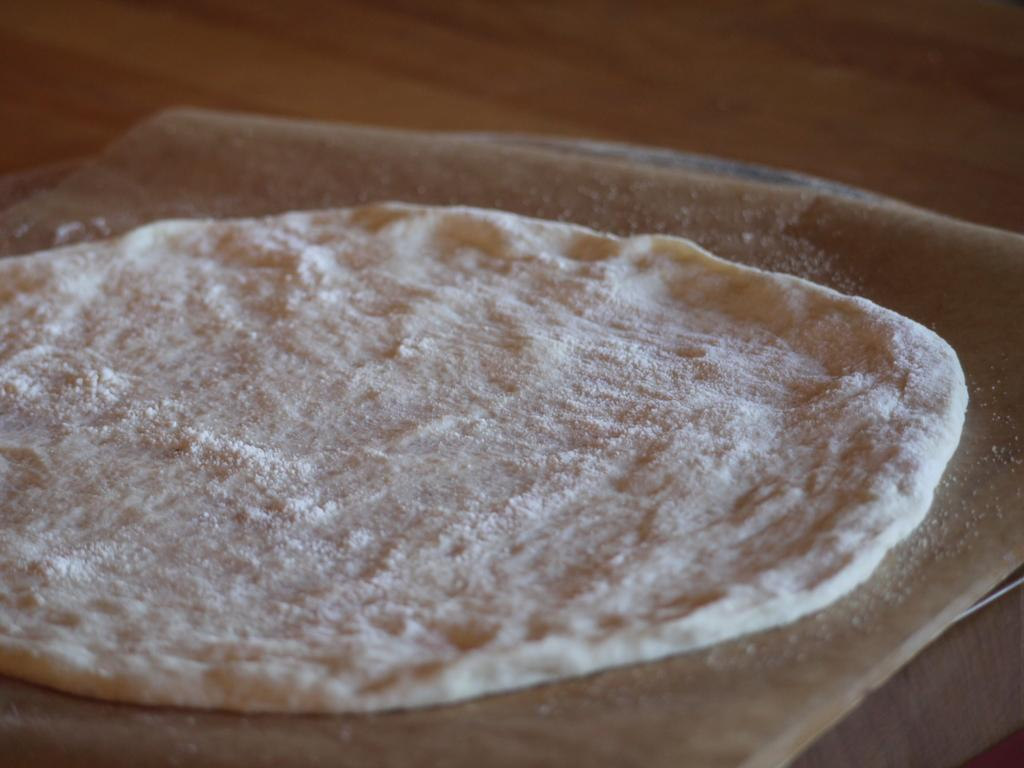What type of food item made with flour can be seen in the image? The specific food item made with flour is not mentioned, but it is present in the image. What is the food item placed on? The food item is placed on an object, but the object is not specified. What can be seen behind the food item and the object? There is a background visible in the image, but its details are not provided. What type of brush is being used to paint the clam on the board in the image? There is no brush, clam, or board present in the image. The image features a food item made with flour placed on an object, with a background visible. 